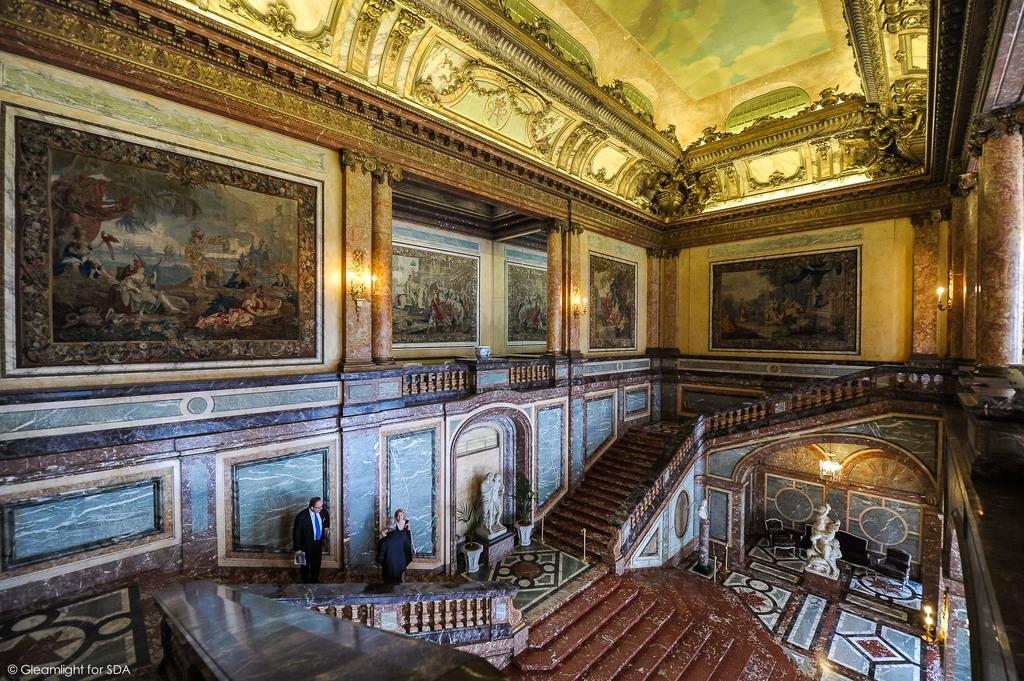Please provide a concise description of this image. In this image we can see the interior of a hall which looks like a palace, it has paintings on the walls and there is a staircase, there are three people on it, there are a few sculptures at the end on the staircases, there are a few other objects like sofas, plants and lights 